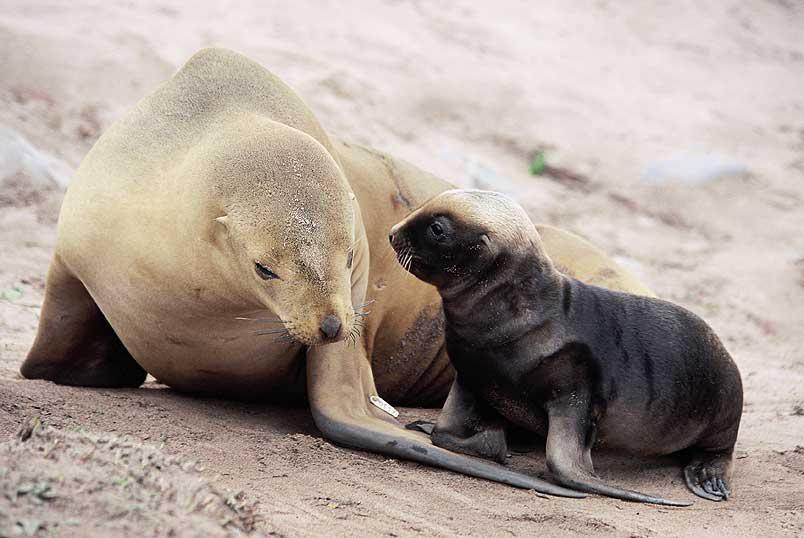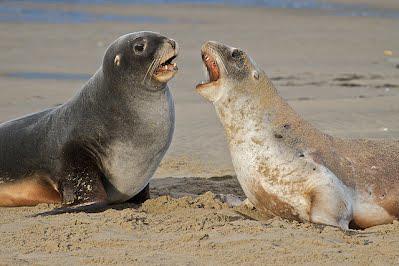The first image is the image on the left, the second image is the image on the right. For the images shown, is this caption "There are no more than five sea animals on the shore." true? Answer yes or no. Yes. The first image is the image on the left, the second image is the image on the right. Analyze the images presented: Is the assertion "An image shows exactly two seals, both with their mouths opened." valid? Answer yes or no. Yes. 